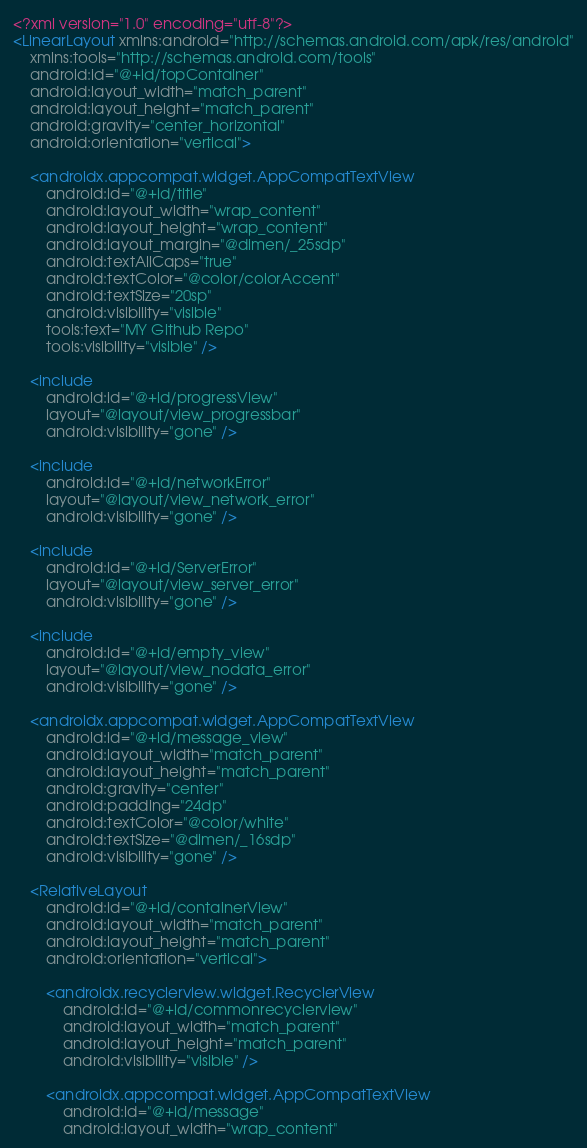<code> <loc_0><loc_0><loc_500><loc_500><_XML_><?xml version="1.0" encoding="utf-8"?>
<LinearLayout xmlns:android="http://schemas.android.com/apk/res/android"
    xmlns:tools="http://schemas.android.com/tools"
    android:id="@+id/topContainer"
    android:layout_width="match_parent"
    android:layout_height="match_parent"
    android:gravity="center_horizontal"
    android:orientation="vertical">

    <androidx.appcompat.widget.AppCompatTextView
        android:id="@+id/title"
        android:layout_width="wrap_content"
        android:layout_height="wrap_content"
        android:layout_margin="@dimen/_25sdp"
        android:textAllCaps="true"
        android:textColor="@color/colorAccent"
        android:textSize="20sp"
        android:visibility="visible"
        tools:text="MY Github Repo"
        tools:visibility="visible" />

    <include
        android:id="@+id/progressView"
        layout="@layout/view_progressbar"
        android:visibility="gone" />

    <include
        android:id="@+id/networkError"
        layout="@layout/view_network_error"
        android:visibility="gone" />

    <include
        android:id="@+id/ServerError"
        layout="@layout/view_server_error"
        android:visibility="gone" />

    <include
        android:id="@+id/empty_view"
        layout="@layout/view_nodata_error"
        android:visibility="gone" />

    <androidx.appcompat.widget.AppCompatTextView
        android:id="@+id/message_view"
        android:layout_width="match_parent"
        android:layout_height="match_parent"
        android:gravity="center"
        android:padding="24dp"
        android:textColor="@color/white"
        android:textSize="@dimen/_16sdp"
        android:visibility="gone" />

    <RelativeLayout
        android:id="@+id/containerView"
        android:layout_width="match_parent"
        android:layout_height="match_parent"
        android:orientation="vertical">

        <androidx.recyclerview.widget.RecyclerView
            android:id="@+id/commonrecyclerview"
            android:layout_width="match_parent"
            android:layout_height="match_parent"
            android:visibility="visible" />

        <androidx.appcompat.widget.AppCompatTextView
            android:id="@+id/message"
            android:layout_width="wrap_content"</code> 